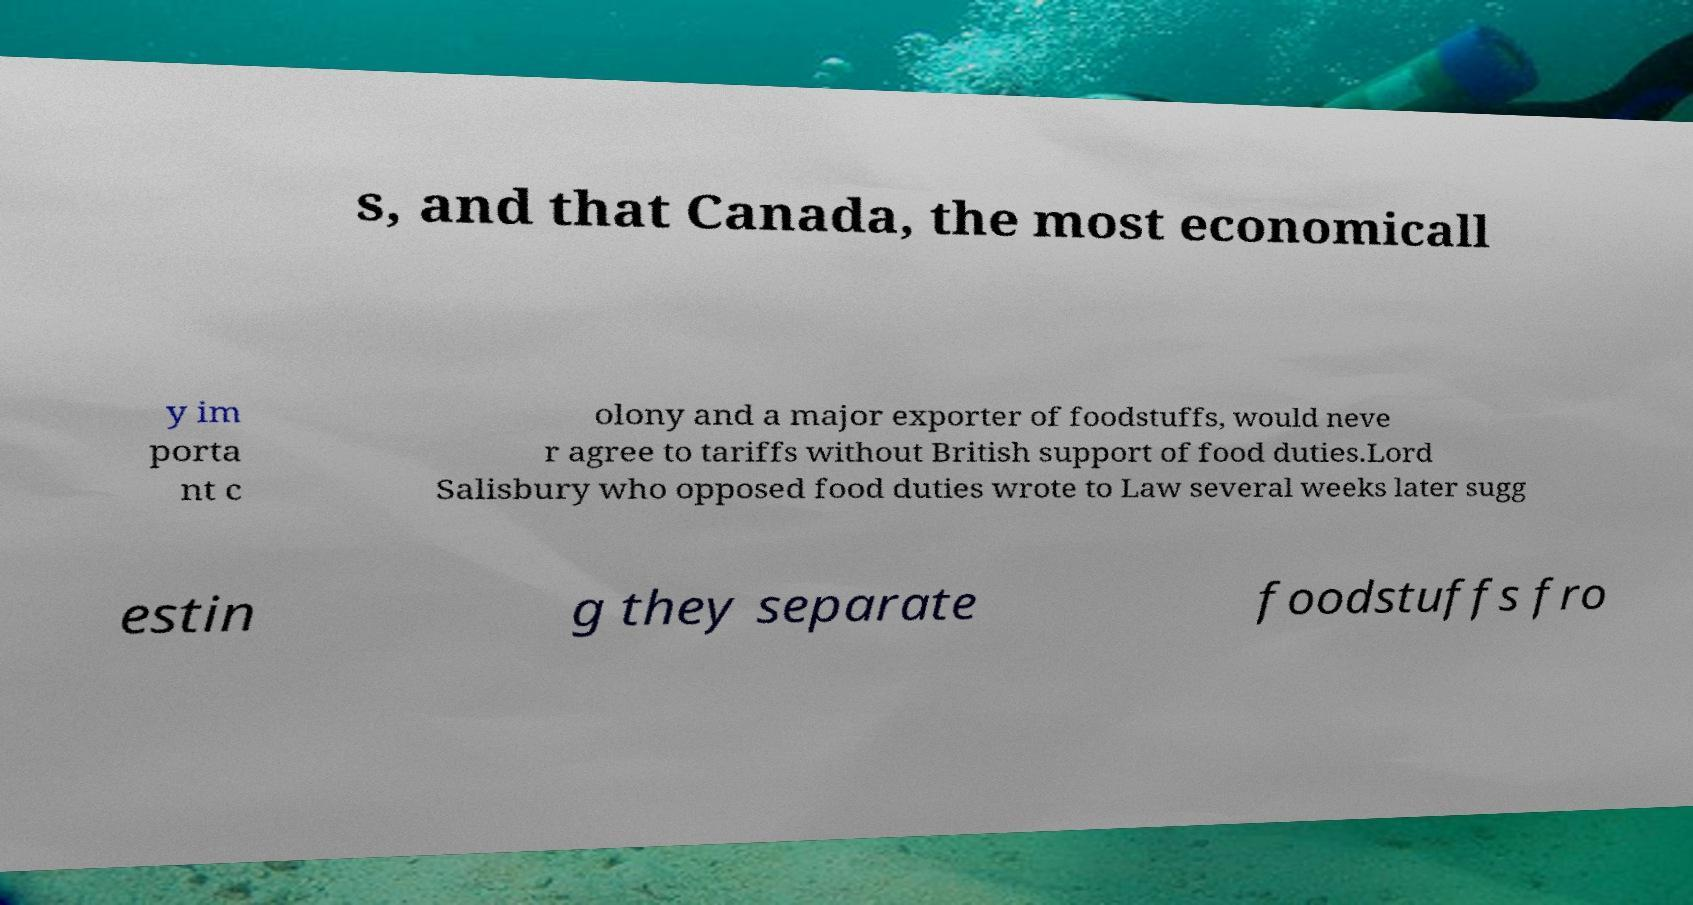There's text embedded in this image that I need extracted. Can you transcribe it verbatim? s, and that Canada, the most economicall y im porta nt c olony and a major exporter of foodstuffs, would neve r agree to tariffs without British support of food duties.Lord Salisbury who opposed food duties wrote to Law several weeks later sugg estin g they separate foodstuffs fro 